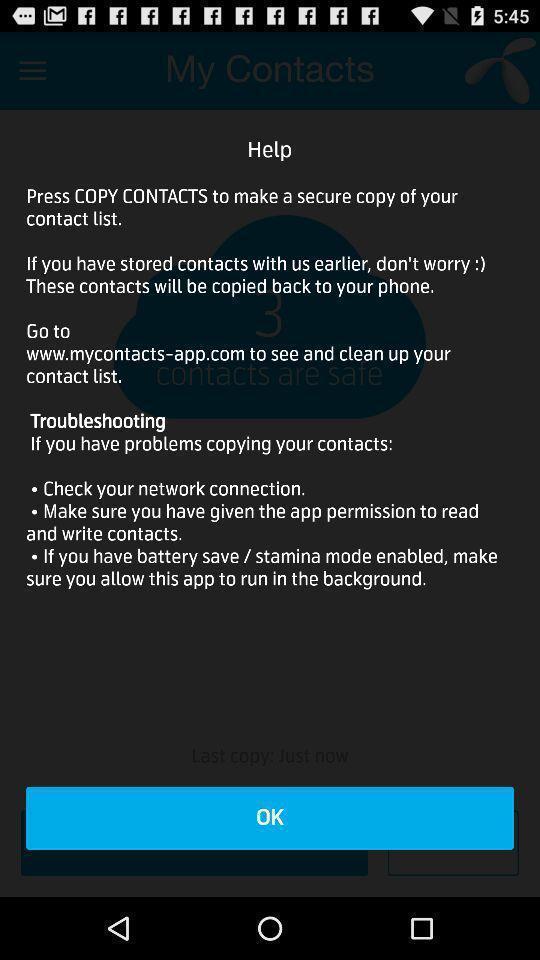Summarize the information in this screenshot. Screen displaying the help page. 